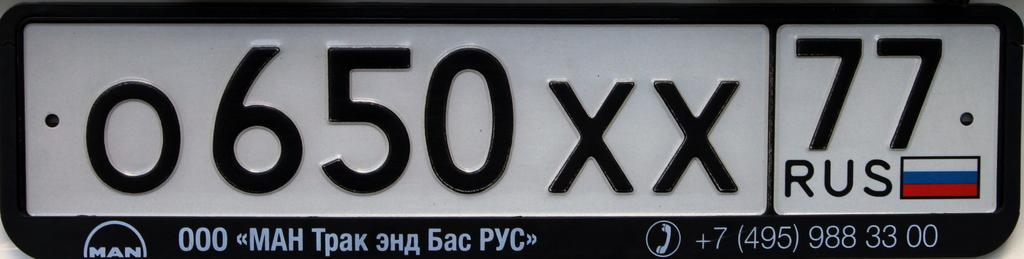What is the main object in the image? There is a number plate board in the image. To which vehicle does the number plate board belong? The number plate board belongs to a vehicle. What additional element is present on the number plate board? There is a flag of a country on the number plate board. What type of insect can be seen crawling on the number plate board in the image? There are no insects present on the number plate board in the image. How does the zebra interact with the number plate board in the image? There are no zebras present in the image, so it is not possible to discuss their interaction with the number plate board. 